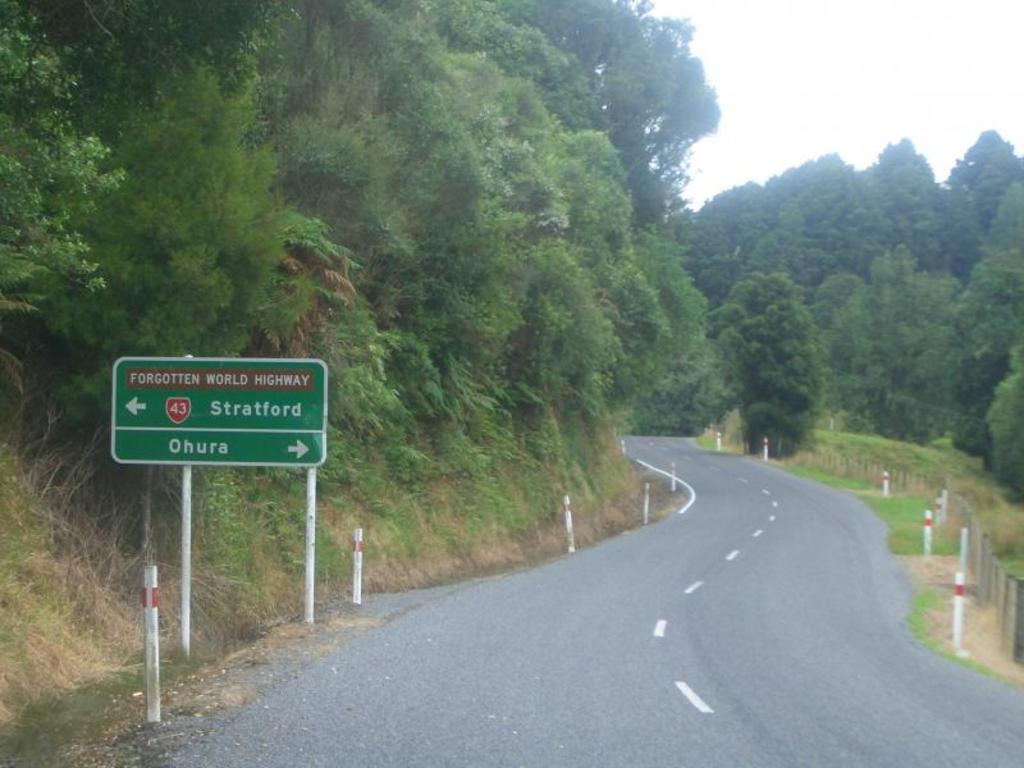<image>
Offer a succinct explanation of the picture presented. A green adn white street sign says strafford with an arrow pointing to the left. 